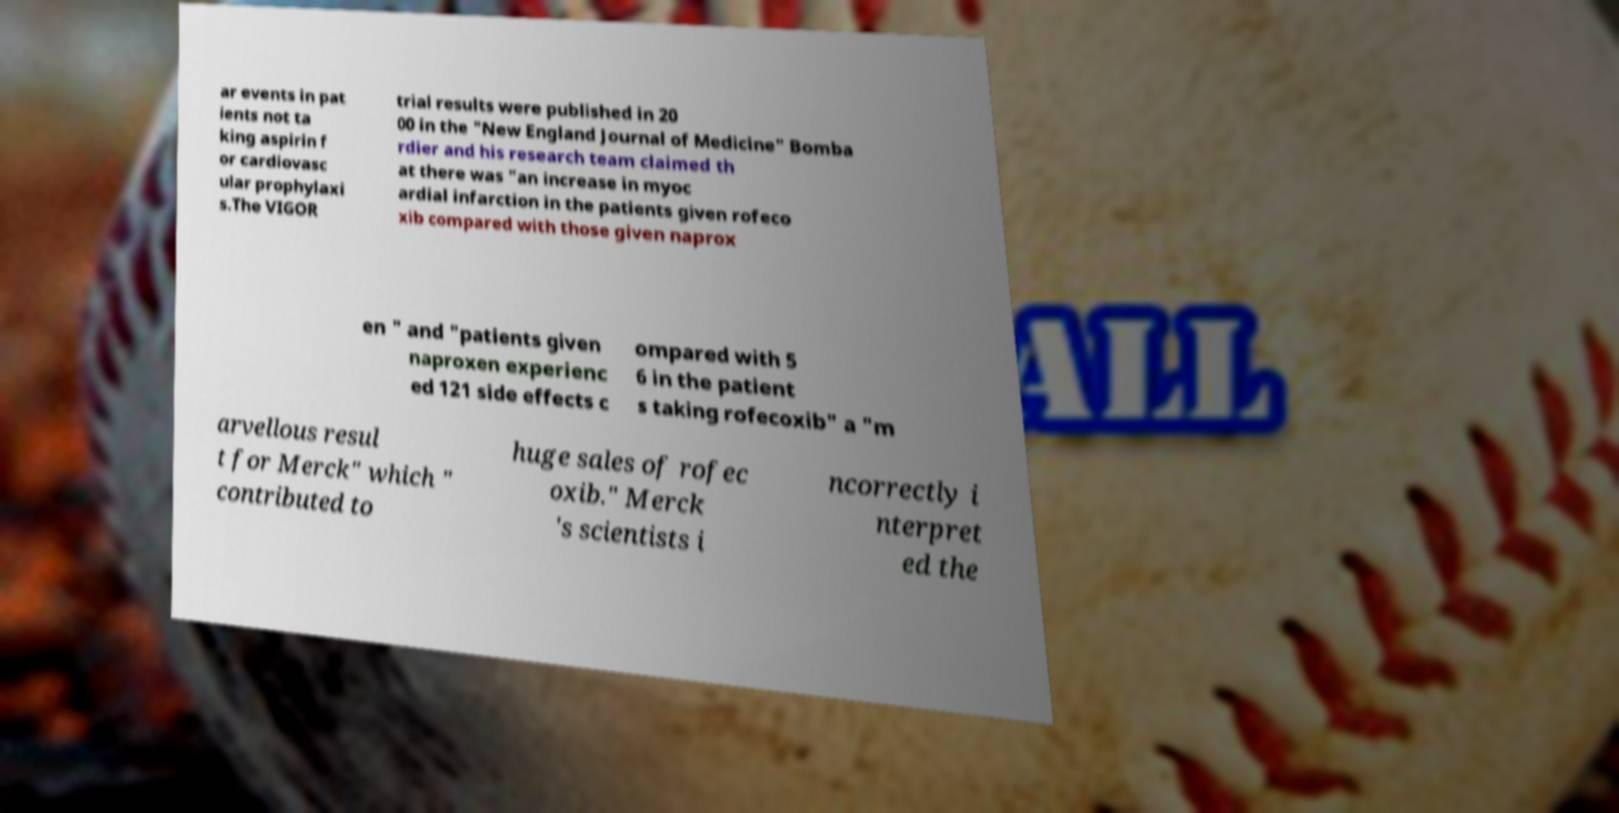There's text embedded in this image that I need extracted. Can you transcribe it verbatim? ar events in pat ients not ta king aspirin f or cardiovasc ular prophylaxi s.The VIGOR trial results were published in 20 00 in the "New England Journal of Medicine" Bomba rdier and his research team claimed th at there was "an increase in myoc ardial infarction in the patients given rofeco xib compared with those given naprox en " and "patients given naproxen experienc ed 121 side effects c ompared with 5 6 in the patient s taking rofecoxib" a "m arvellous resul t for Merck" which " contributed to huge sales of rofec oxib." Merck 's scientists i ncorrectly i nterpret ed the 